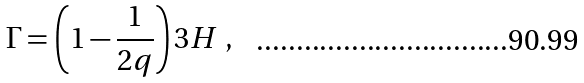<formula> <loc_0><loc_0><loc_500><loc_500>\Gamma = \left ( 1 - \frac { 1 } { 2 q } \right ) 3 H \ ,</formula> 